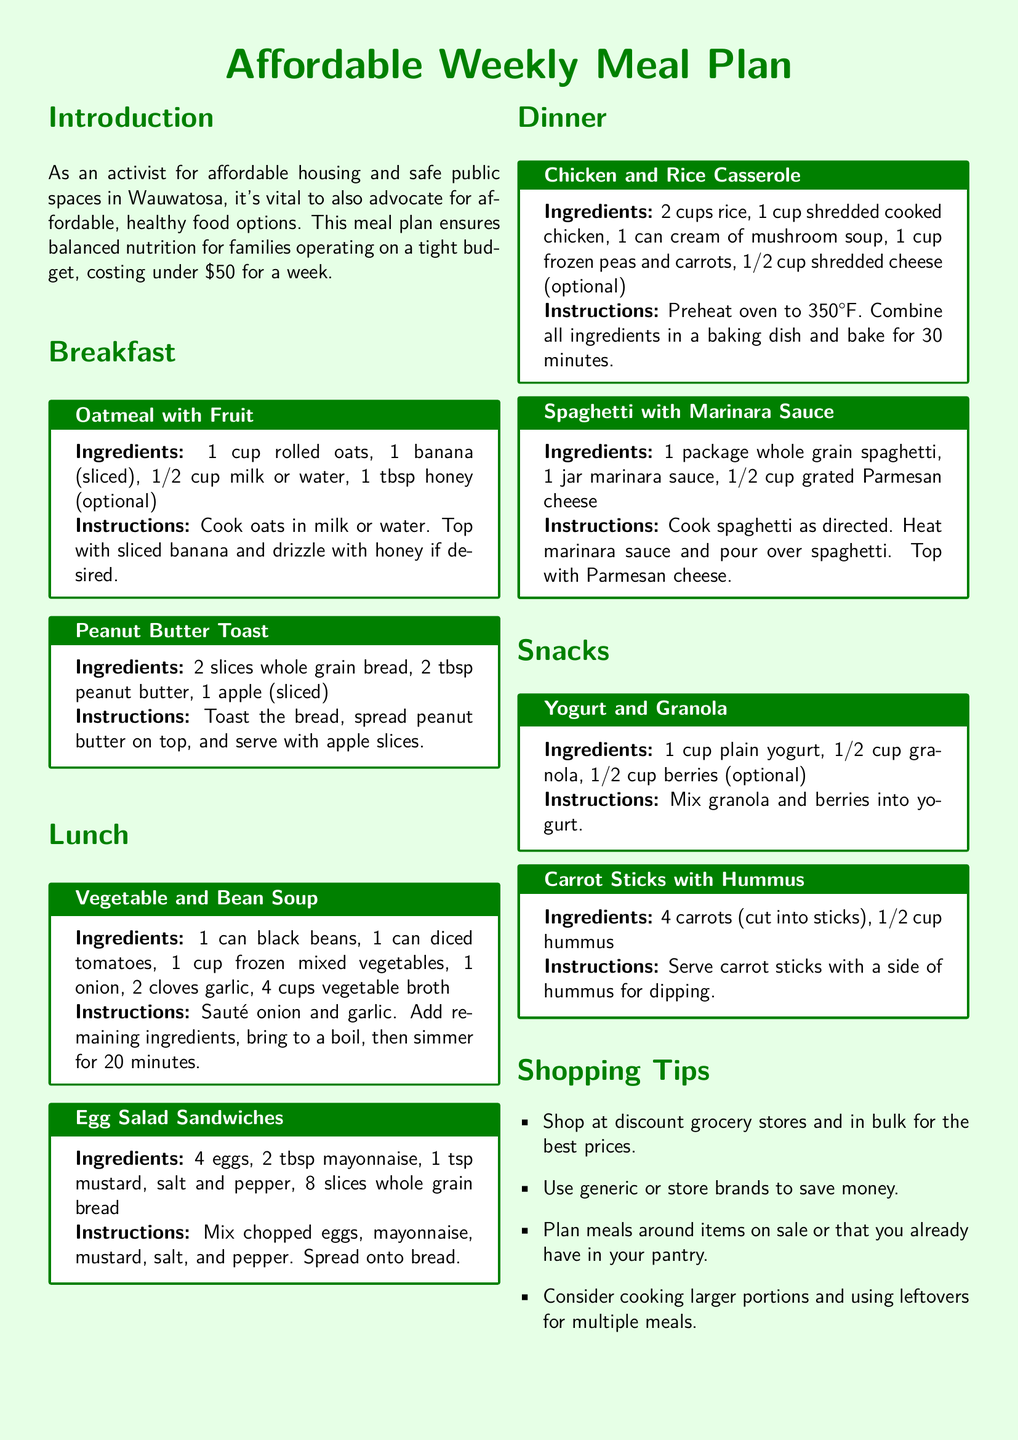What is the total cost of the meal plan? The document states that the meal plan costs under $50 for a week.
Answer: under $50 How many meals are included in the meal plan? The meal plan includes breakfast, lunch, dinner, and snacks, totaling four meal categories.
Answer: 4 What ingredient is common in both breakfast options? Both breakfast options include a form of carbohydrate: oats and whole grain bread.
Answer: carbohydrate What is one recommended shopping tip? The document provides multiple tips and one of them is to shop at discount grocery stores for the best prices.
Answer: shop at discount grocery stores What vegetable is used in the Vegetable and Bean Soup? The soup includes frozen mixed vegetables as an ingredient.
Answer: frozen mixed vegetables What can be served alongside carrot sticks? The instructions mention serving carrot sticks with hummus for dipping.
Answer: hummus What is the main ingredient in the Egg Salad Sandwiches? The main ingredient listed for the Egg Salad Sandwiches is eggs.
Answer: eggs How long should the Chicken and Rice Casserole be baked? The recipe states to bake the casserole for 30 minutes.
Answer: 30 minutes What role does honey play in the breakfast oatmeal? Honey is listed as an optional ingredient to sweeten the oatmeal.
Answer: sweeten 